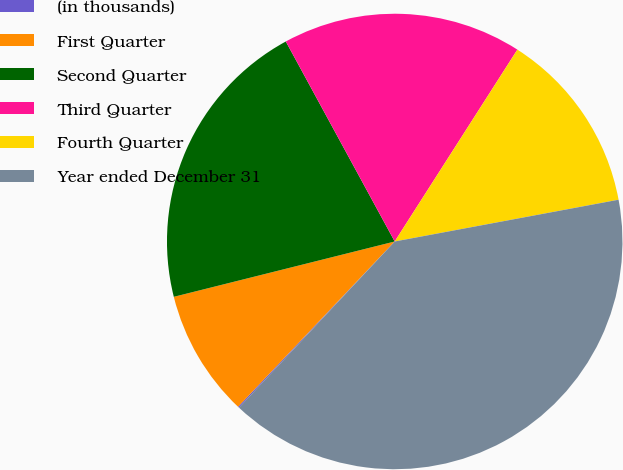<chart> <loc_0><loc_0><loc_500><loc_500><pie_chart><fcel>(in thousands)<fcel>First Quarter<fcel>Second Quarter<fcel>Third Quarter<fcel>Fourth Quarter<fcel>Year ended December 31<nl><fcel>0.09%<fcel>9.02%<fcel>20.97%<fcel>16.99%<fcel>13.01%<fcel>39.92%<nl></chart> 